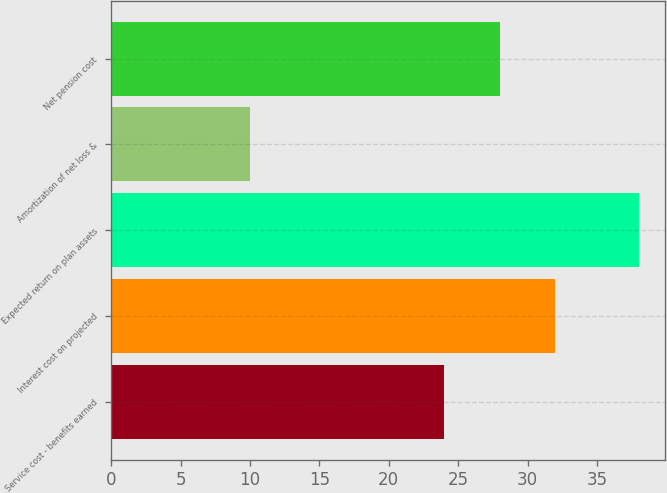Convert chart to OTSL. <chart><loc_0><loc_0><loc_500><loc_500><bar_chart><fcel>Service cost - benefits earned<fcel>Interest cost on projected<fcel>Expected return on plan assets<fcel>Amortization of net loss &<fcel>Net pension cost<nl><fcel>24<fcel>32<fcel>38<fcel>10<fcel>28<nl></chart> 